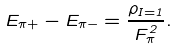Convert formula to latex. <formula><loc_0><loc_0><loc_500><loc_500>E _ { \pi + } - E _ { \pi - } = \frac { \rho _ { I = 1 } } { F _ { \pi } ^ { 2 } } .</formula> 